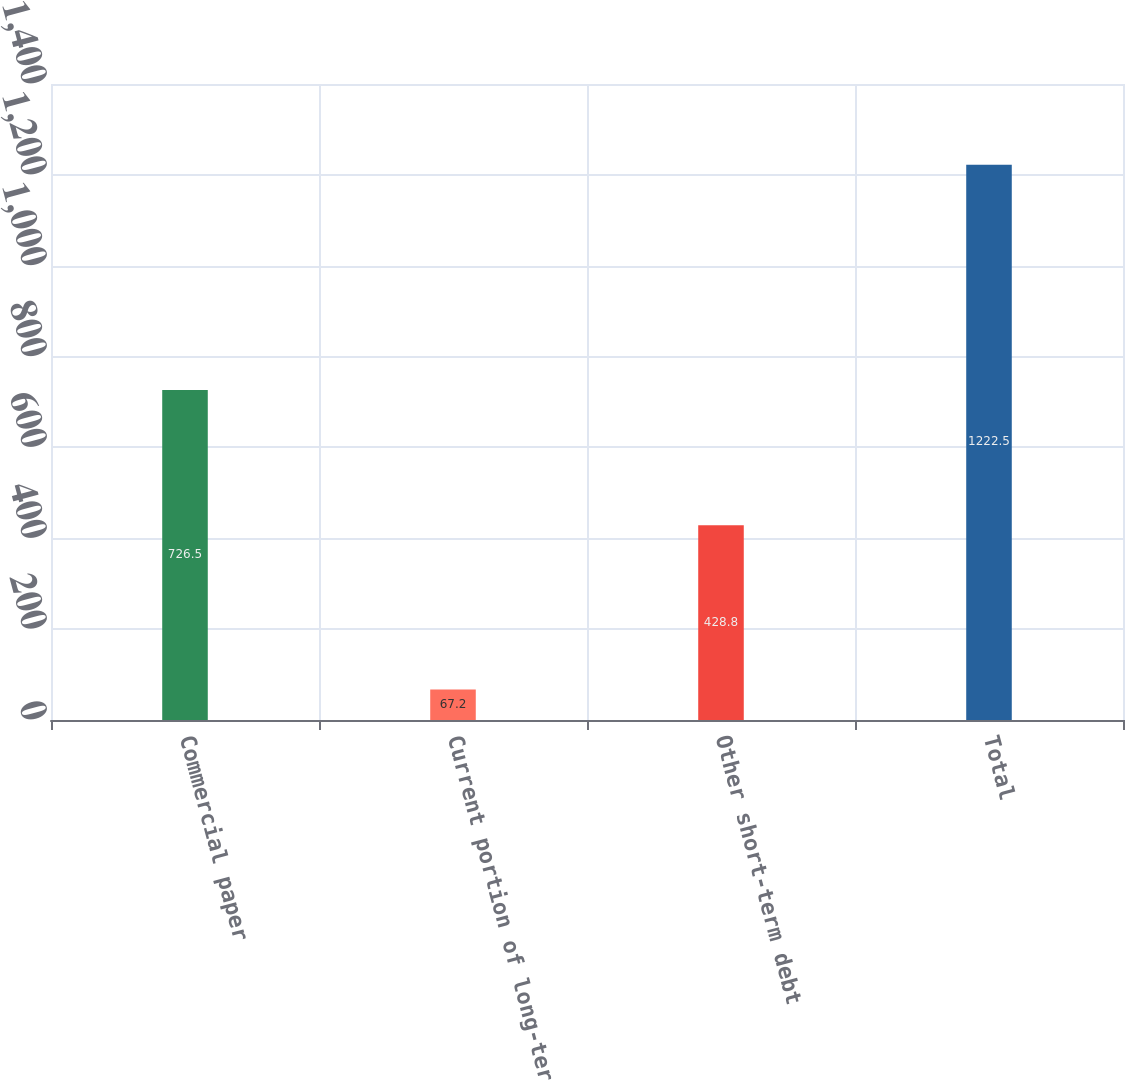<chart> <loc_0><loc_0><loc_500><loc_500><bar_chart><fcel>Commercial paper<fcel>Current portion of long-term<fcel>Other short-term debt<fcel>Total<nl><fcel>726.5<fcel>67.2<fcel>428.8<fcel>1222.5<nl></chart> 